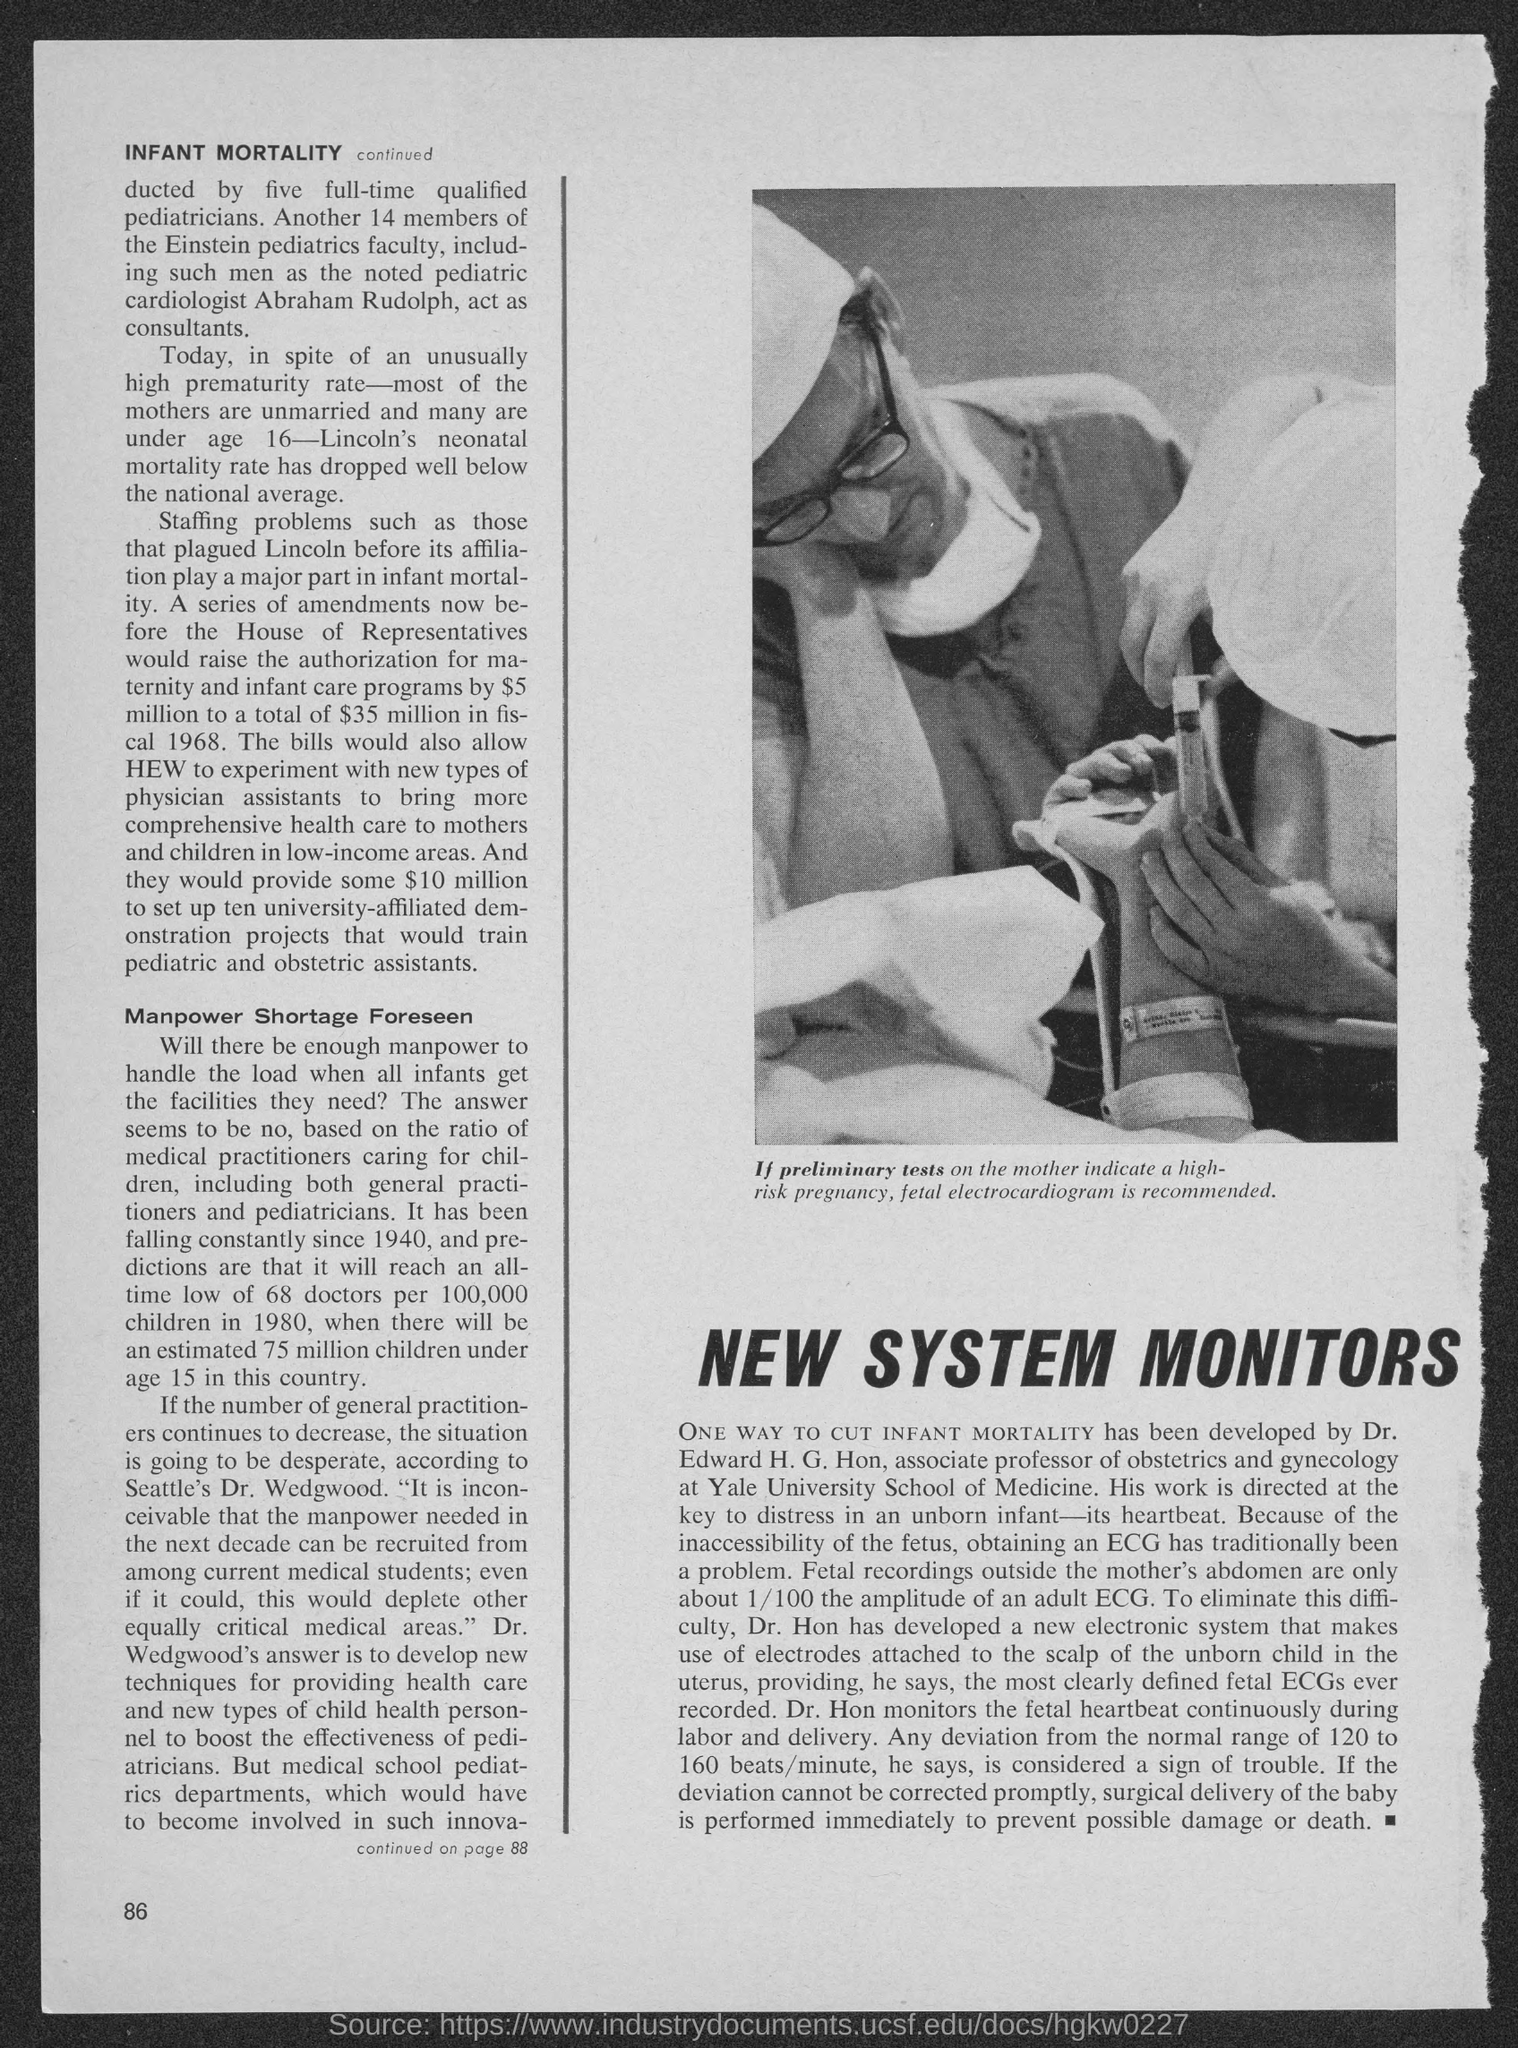Identify some key points in this picture. Dr. Edward H. G. Hon has developed a method for reducing infant mortality. If the tests conducted on the mother indicate a high-risk pregnancy, it is recommended to perform a fetal electrocardiogram (ECG) to monitor the baby's heart rate and ensure proper development. 